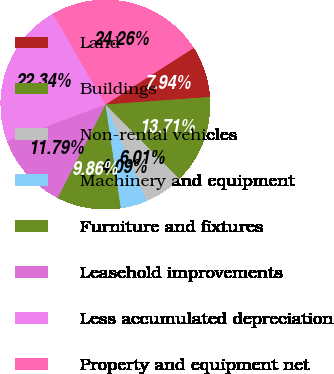Convert chart to OTSL. <chart><loc_0><loc_0><loc_500><loc_500><pie_chart><fcel>Land<fcel>Buildings<fcel>Non-rental vehicles<fcel>Machinery and equipment<fcel>Furniture and fixtures<fcel>Leasehold improvements<fcel>Less accumulated depreciation<fcel>Property and equipment net<nl><fcel>7.94%<fcel>13.71%<fcel>6.01%<fcel>4.09%<fcel>9.86%<fcel>11.79%<fcel>22.34%<fcel>24.26%<nl></chart> 